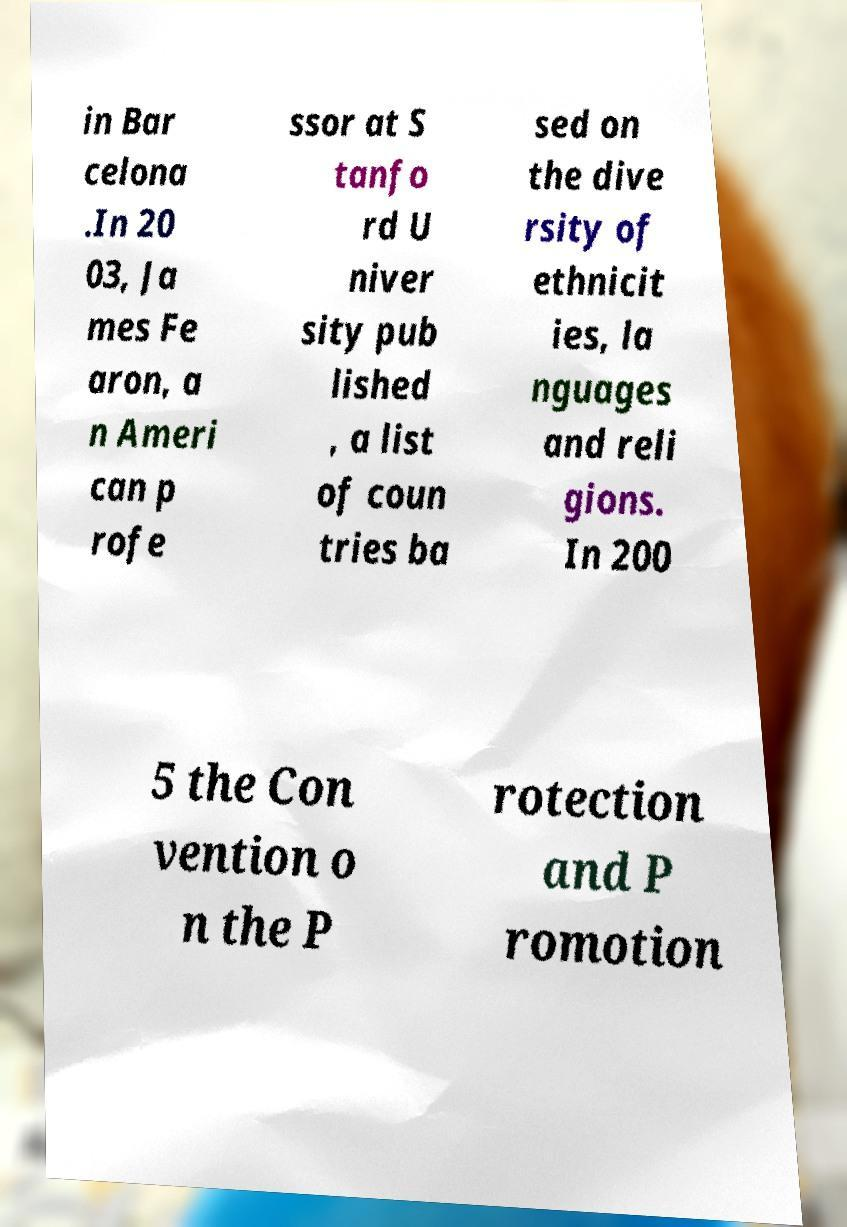I need the written content from this picture converted into text. Can you do that? in Bar celona .In 20 03, Ja mes Fe aron, a n Ameri can p rofe ssor at S tanfo rd U niver sity pub lished , a list of coun tries ba sed on the dive rsity of ethnicit ies, la nguages and reli gions. In 200 5 the Con vention o n the P rotection and P romotion 